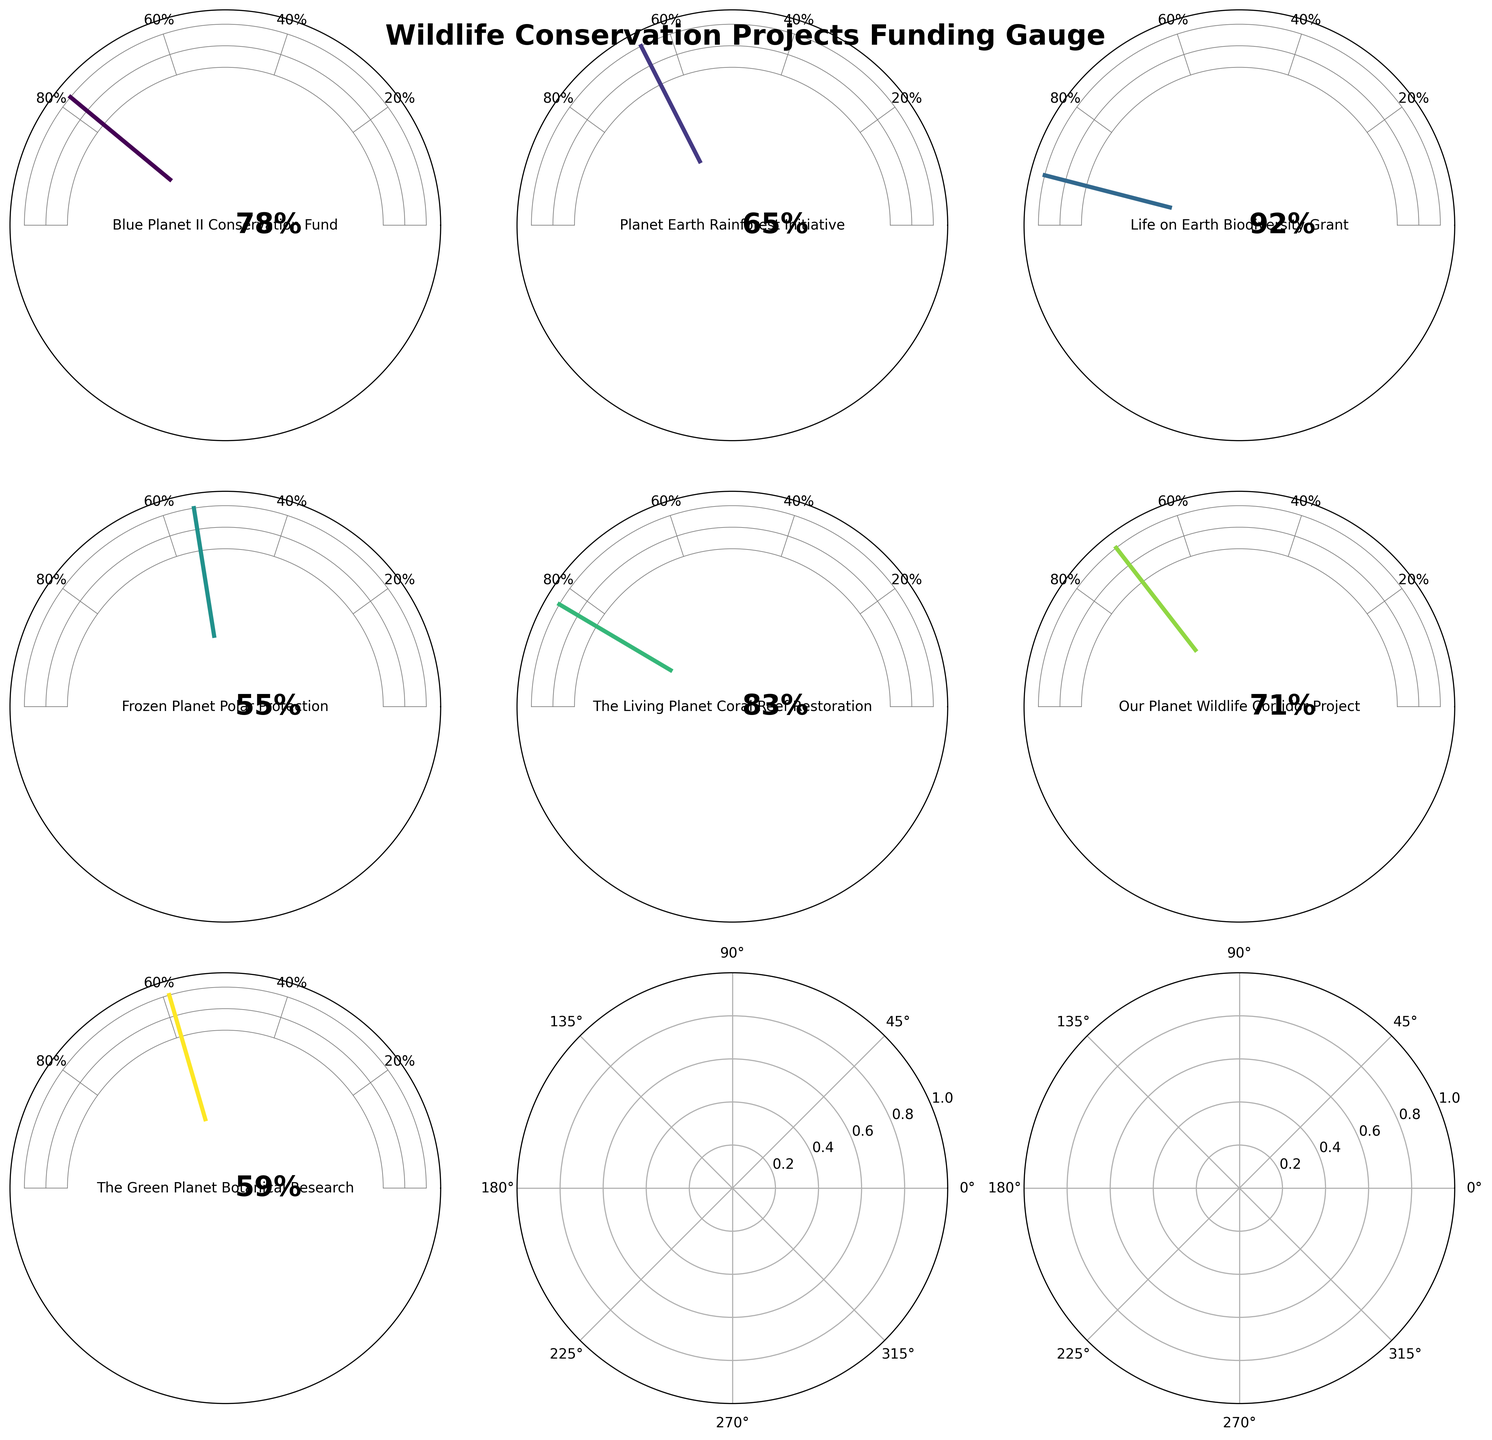Which project received the highest funding allocation? The highest funding percentage is identified as 92% on the gauge chart for the Life on Earth Biodiversity Grant project.
Answer: Life on Earth Biodiversity Grant Which project received the lowest funding allocation? The lowest funding percentage is identified as 55% on the gauge chart for the Frozen Planet Polar Protection project.
Answer: Frozen Planet Polar Protection How many projects received funding allocations of more than 70%? Identifying the projects with funding percentages above 70%: Blue Planet II Conservation Fund, Planet Earth Rainforest Initiative, Life on Earth Biodiversity Grant, The Living Planet Coral Reef Restoration, and Our Planet Wildlife Corridor Project. There are 5 such projects.
Answer: 5 What's the difference in funding allocation percentages between the Blue Planet II Conservation Fund and the Frozen Planet Polar Protection project? Blue Planet II Conservation Fund received 78% while Frozen Planet Polar Protection received 55%. The difference is 78 - 55 = 23%.
Answer: 23% What is the average funding allocation percentage among all projects? Calculating the average: (78 + 65 + 92 + 55 + 83 + 71 + 59)/7 ≈ 71.86
Answer: 71.86% 